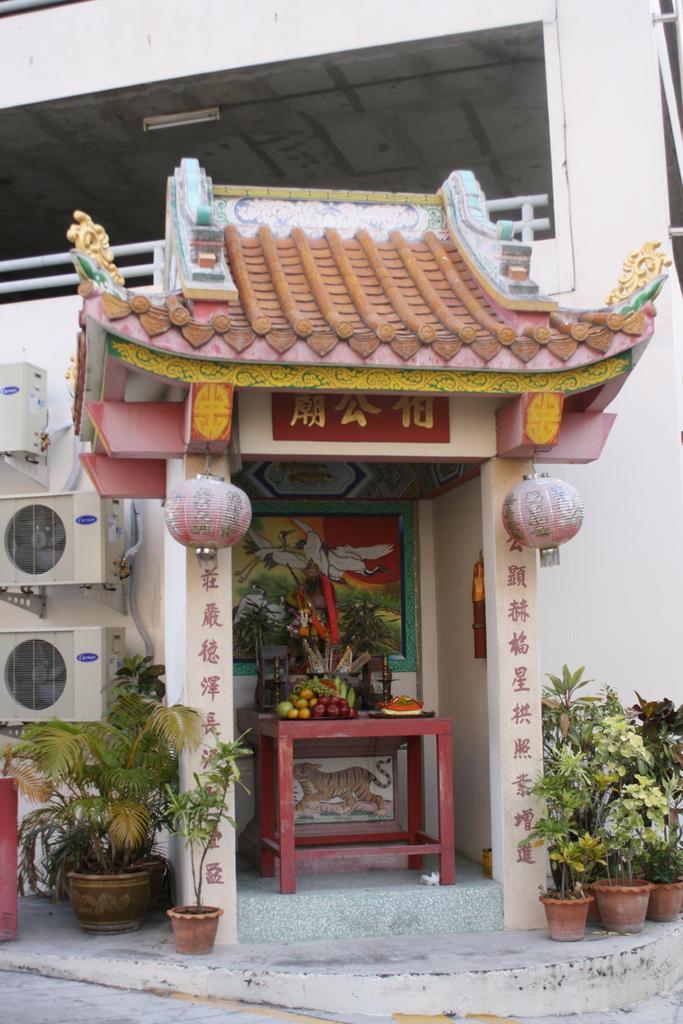How would you summarize this image in a sentence or two? In this image I can see few fruits in the brown color tray and the tray is on the table. In the background I can see the board attached to the wall. In front I can see an arch, few plants in green color and I can see three air conditioners and the wall is in white color and I can also see the railing. 